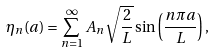<formula> <loc_0><loc_0><loc_500><loc_500>\eta _ { n } ( a ) = \sum _ { n = 1 } ^ { \infty } A _ { n } \sqrt { \frac { 2 } { L } } \sin \left ( { \frac { n \pi a } { L } } \right ) ,</formula> 